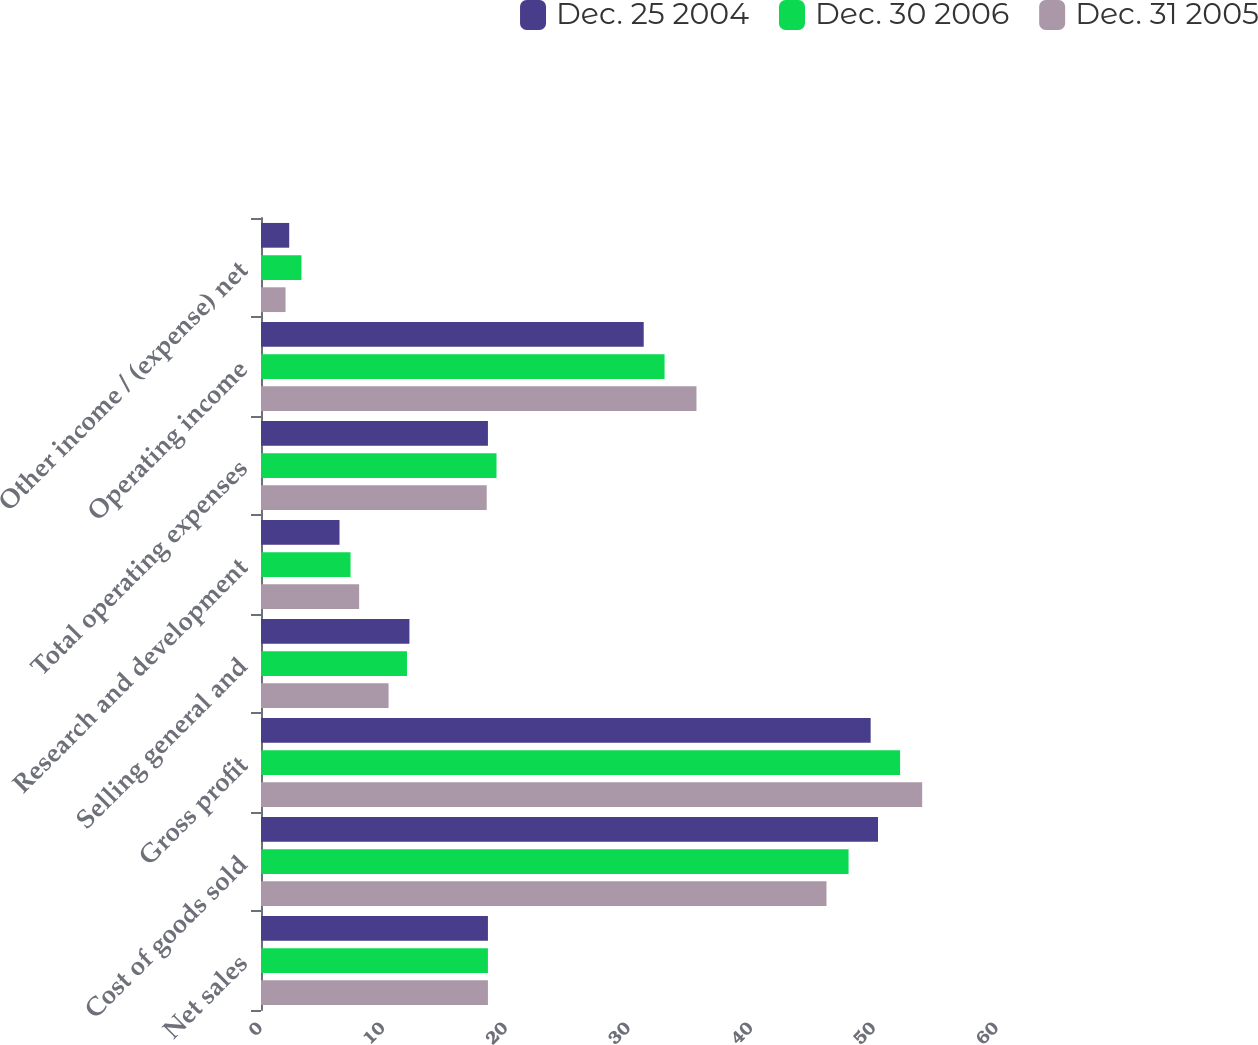<chart> <loc_0><loc_0><loc_500><loc_500><stacked_bar_chart><ecel><fcel>Net sales<fcel>Cost of goods sold<fcel>Gross profit<fcel>Selling general and<fcel>Research and development<fcel>Total operating expenses<fcel>Operating income<fcel>Other income / (expense) net<nl><fcel>Dec. 25 2004<fcel>18.5<fcel>50.3<fcel>49.7<fcel>12.1<fcel>6.4<fcel>18.5<fcel>31.2<fcel>2.3<nl><fcel>Dec. 30 2006<fcel>18.5<fcel>47.9<fcel>52.1<fcel>11.9<fcel>7.3<fcel>19.2<fcel>32.9<fcel>3.3<nl><fcel>Dec. 31 2005<fcel>18.5<fcel>46.1<fcel>53.9<fcel>10.4<fcel>8<fcel>18.4<fcel>35.5<fcel>2<nl></chart> 